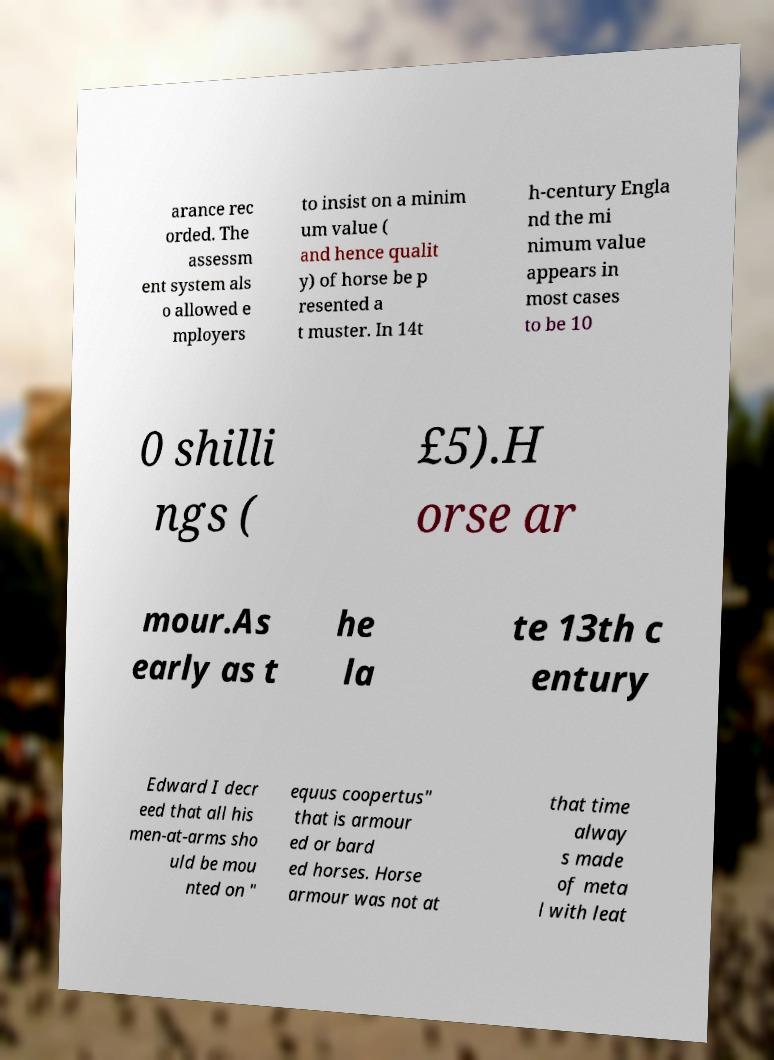Could you assist in decoding the text presented in this image and type it out clearly? arance rec orded. The assessm ent system als o allowed e mployers to insist on a minim um value ( and hence qualit y) of horse be p resented a t muster. In 14t h-century Engla nd the mi nimum value appears in most cases to be 10 0 shilli ngs ( £5).H orse ar mour.As early as t he la te 13th c entury Edward I decr eed that all his men-at-arms sho uld be mou nted on " equus coopertus" that is armour ed or bard ed horses. Horse armour was not at that time alway s made of meta l with leat 